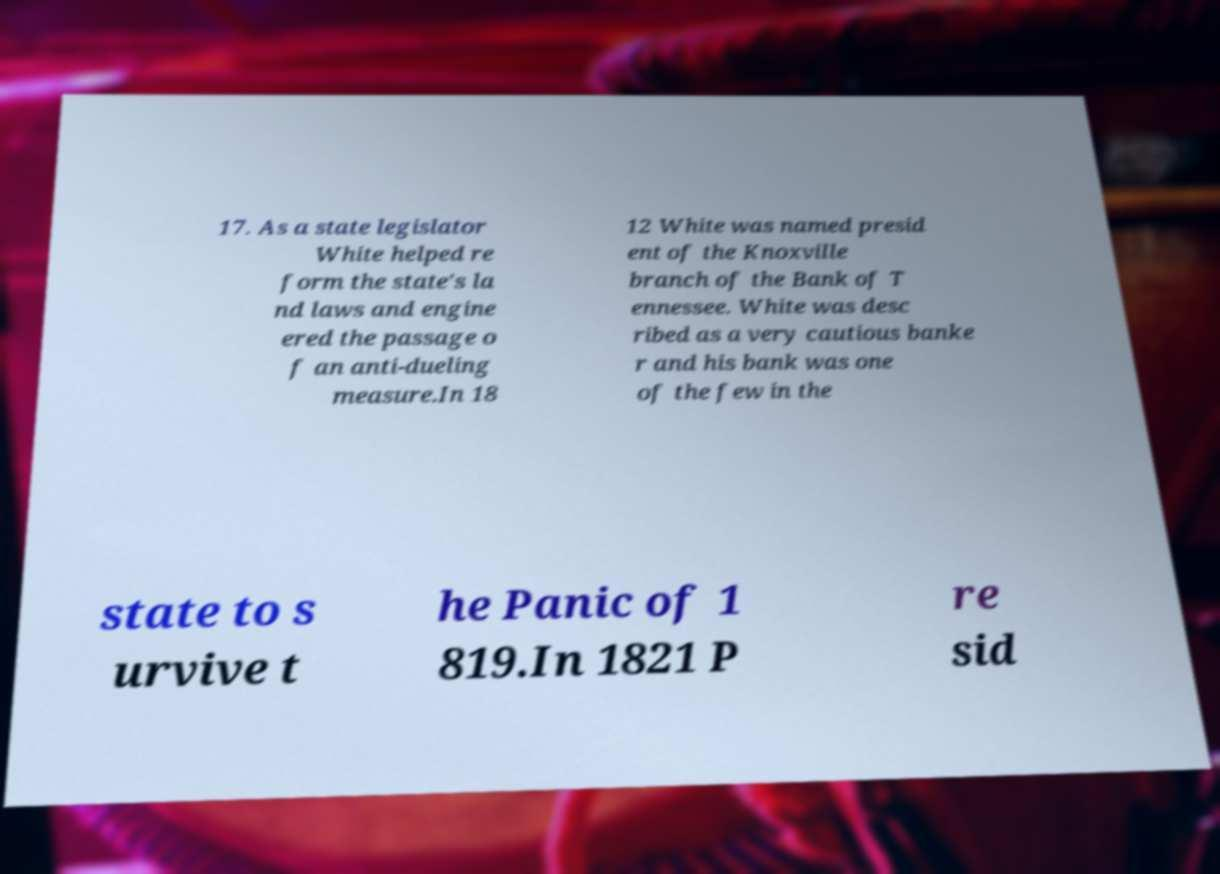For documentation purposes, I need the text within this image transcribed. Could you provide that? 17. As a state legislator White helped re form the state's la nd laws and engine ered the passage o f an anti-dueling measure.In 18 12 White was named presid ent of the Knoxville branch of the Bank of T ennessee. White was desc ribed as a very cautious banke r and his bank was one of the few in the state to s urvive t he Panic of 1 819.In 1821 P re sid 